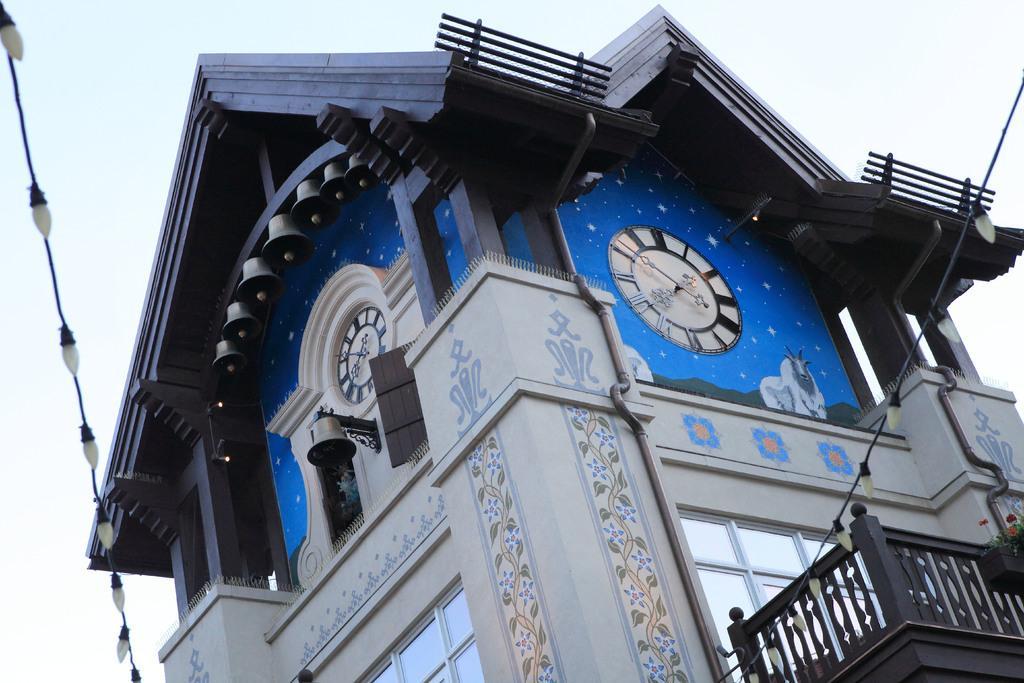How would you summarize this image in a sentence or two? In the middle of the picture we can see a building and there are two clocks. This is a fence, light, cable wire and a white sky. 